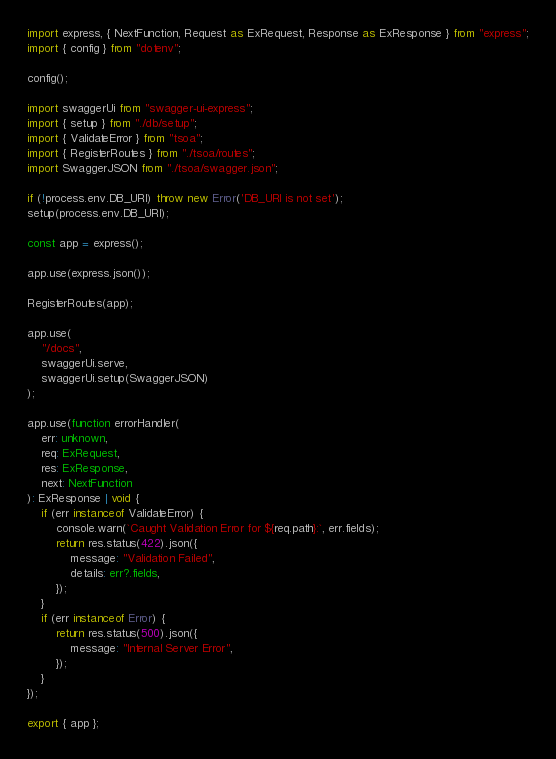Convert code to text. <code><loc_0><loc_0><loc_500><loc_500><_TypeScript_>import express, { NextFunction, Request as ExRequest, Response as ExResponse } from "express";
import { config } from "dotenv";

config();

import swaggerUi from "swagger-ui-express";
import { setup } from "./db/setup";
import { ValidateError } from "tsoa";
import { RegisterRoutes } from "./tsoa/routes";
import SwaggerJSON from "./tsoa/swagger.json";

if (!process.env.DB_URI) throw new Error('DB_URI is not set');
setup(process.env.DB_URI);

const app = express();

app.use(express.json());

RegisterRoutes(app);

app.use(
    "/docs",
    swaggerUi.serve,
    swaggerUi.setup(SwaggerJSON)
);

app.use(function errorHandler(
    err: unknown,
    req: ExRequest,
    res: ExResponse,
    next: NextFunction
): ExResponse | void {
    if (err instanceof ValidateError) {
        console.warn(`Caught Validation Error for ${req.path}:`, err.fields);
        return res.status(422).json({
            message: "Validation Failed",
            details: err?.fields,
        });
    }
    if (err instanceof Error) {
        return res.status(500).json({
            message: "Internal Server Error",
        });
    }
});

export { app };
</code> 